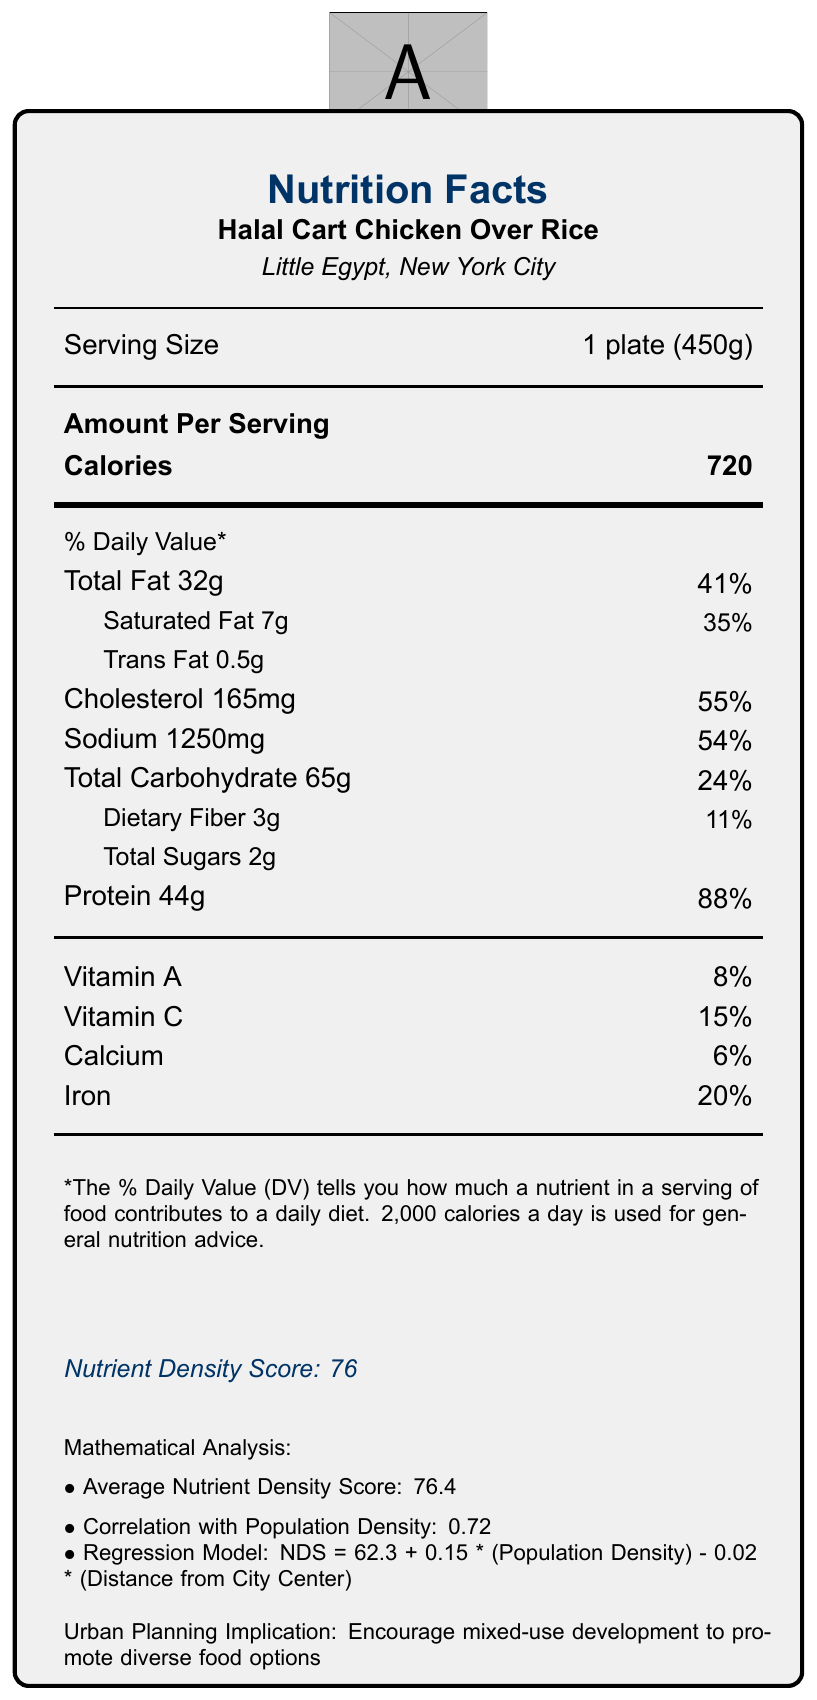what is the serving size of Halal Cart Chicken Over Rice? The serving size is specified directly under the section titled "Serving Size" in the document.
Answer: 1 plate (450g) how many calories are in a serving of Halal Cart Chicken Over Rice? The calorie count is indicated under the "Amount Per Serving" section, next to the word "Calories."
Answer: 720 what is the nutrient density score of Falafel Wrap? The nutrient density score for each street food item is listed at the bottom of the section, following the nutritional details.
Answer: 82 which street food has the highest protein content? A. Halal Cart Chicken Over Rice B. Carne Asada Taco C. Falafel Wrap D. Bánh Mì E. Jerk Chicken with Rice and Peas The protein content for Halal Cart Chicken Over Rice is 44g, which is the highest among the listed street foods.
Answer: A what is the vitamin C content of Jerk Chicken with Rice and Peas? The vitamin C content is recorded under the vitamins section for Jerk Chicken with Rice and Peas.
Answer: 30% what is the equation of the regression model mentioned in the mathematical analysis? The regression model equation is directly presented in the mathematical analysis section of the document.
Answer: NDS = 62.3 + 0.15 * (Population Density) - 0.02 * (Distance from City Center) what urban planning recommendation can be inferred from the document? The urban planning recommendation is stated towards the end of the document in the urban planning implications section.
Answer: Encourage mixed-use development to promote diverse food options what percentage of daily value of sodium is present in Halal Cart Chicken Over Rice? The percentage daily value of sodium is listed next to the sodium content amount (1250mg) in the document.
Answer: 54% which nutrient has the highest percentage daily value in Halal Cart Chicken Over Rice? A. Total Fat B. Saturated Fat C. Cholesterol D. Sodium Cholesterol has the highest percentage daily value at 55%, as listed in the nutritional information.
Answer: C is there any correlation provided between nutrient density scores and population density? The document mentions a correlation of 0.72 between nutrient density scores and population density in the mathematical analysis section.
Answer: Yes describe the main points of the entire document. The document summarizes the nutritional content of different street foods, presents mathematical analyses for understanding the data, and offers insights into urban planning, public health, and economic implications.
Answer: The document provides detailed nutritional information for various street foods from different cultural neighborhoods and includes a nutrient density score for each. It also outlines mathematical analyses such as average nutrient density score, correlation with population density, and a regression model for predicting nutrient density scores. Additionally, it discusses urban planning implications, public health considerations, and economic impact. what percentage of calcium is present in Falafel Wrap? The percentage daily value for calcium is listed under the vitamins and minerals section for the Falafel Wrap.
Answer: 12% how many grams of saturated fat are in Bánh Mì? The amount of saturated fat is indicated in the nutritional details for Bánh Mì.
Answer: 3g what is the main method used for clustering analysis in the document? The clustering method used is specified as K-means in the mathematical analysis section.
Answer: K-means can we determine the price of each serving from this document? The document does not provide any pricing details for the street foods, so we cannot determine their prices.
Answer: Not enough information 